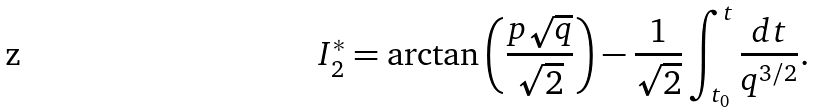Convert formula to latex. <formula><loc_0><loc_0><loc_500><loc_500>I _ { 2 } ^ { * } = \arctan \left ( \frac { p \sqrt { q } } { \sqrt { 2 } } \right ) - \frac { 1 } { \sqrt { 2 } } \int _ { t _ { 0 } } ^ { t } \frac { d t } { q ^ { 3 / 2 } } .</formula> 